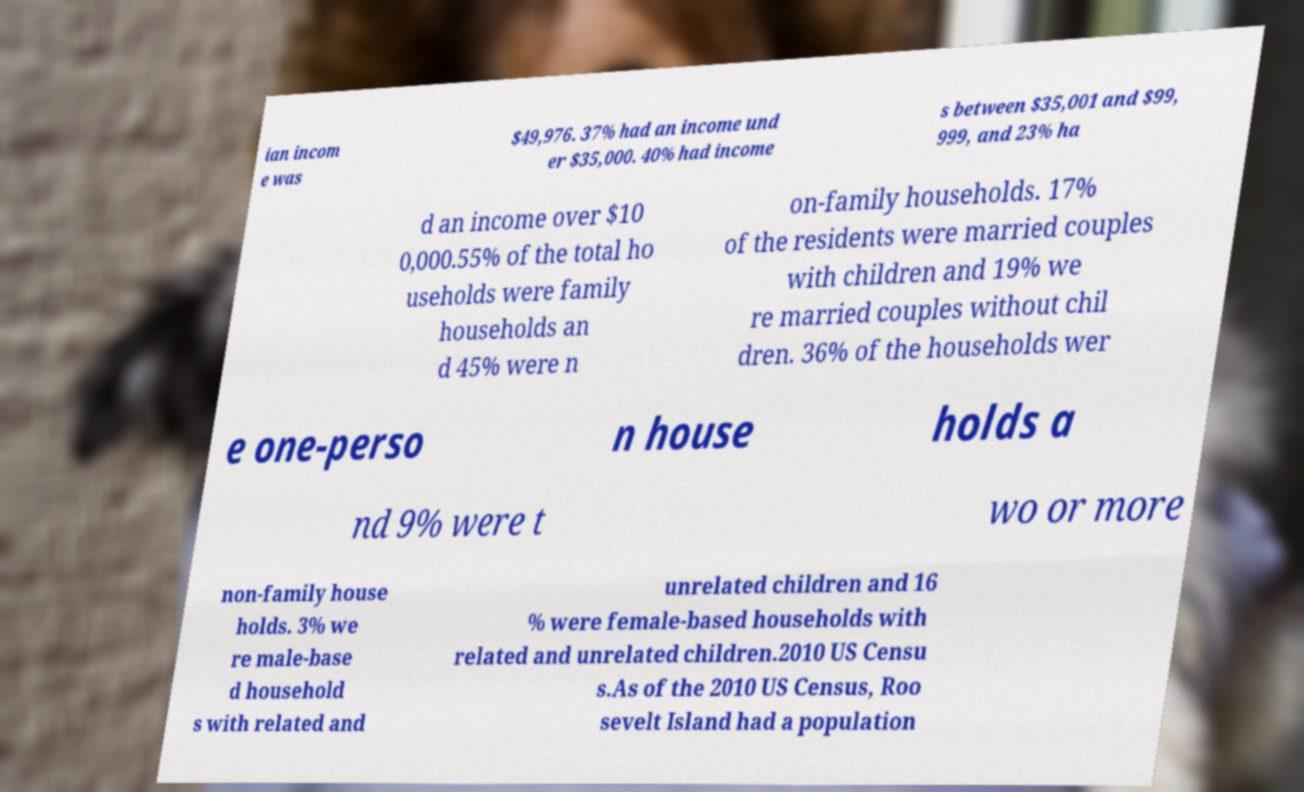For documentation purposes, I need the text within this image transcribed. Could you provide that? ian incom e was $49,976. 37% had an income und er $35,000. 40% had income s between $35,001 and $99, 999, and 23% ha d an income over $10 0,000.55% of the total ho useholds were family households an d 45% were n on-family households. 17% of the residents were married couples with children and 19% we re married couples without chil dren. 36% of the households wer e one-perso n house holds a nd 9% were t wo or more non-family house holds. 3% we re male-base d household s with related and unrelated children and 16 % were female-based households with related and unrelated children.2010 US Censu s.As of the 2010 US Census, Roo sevelt Island had a population 